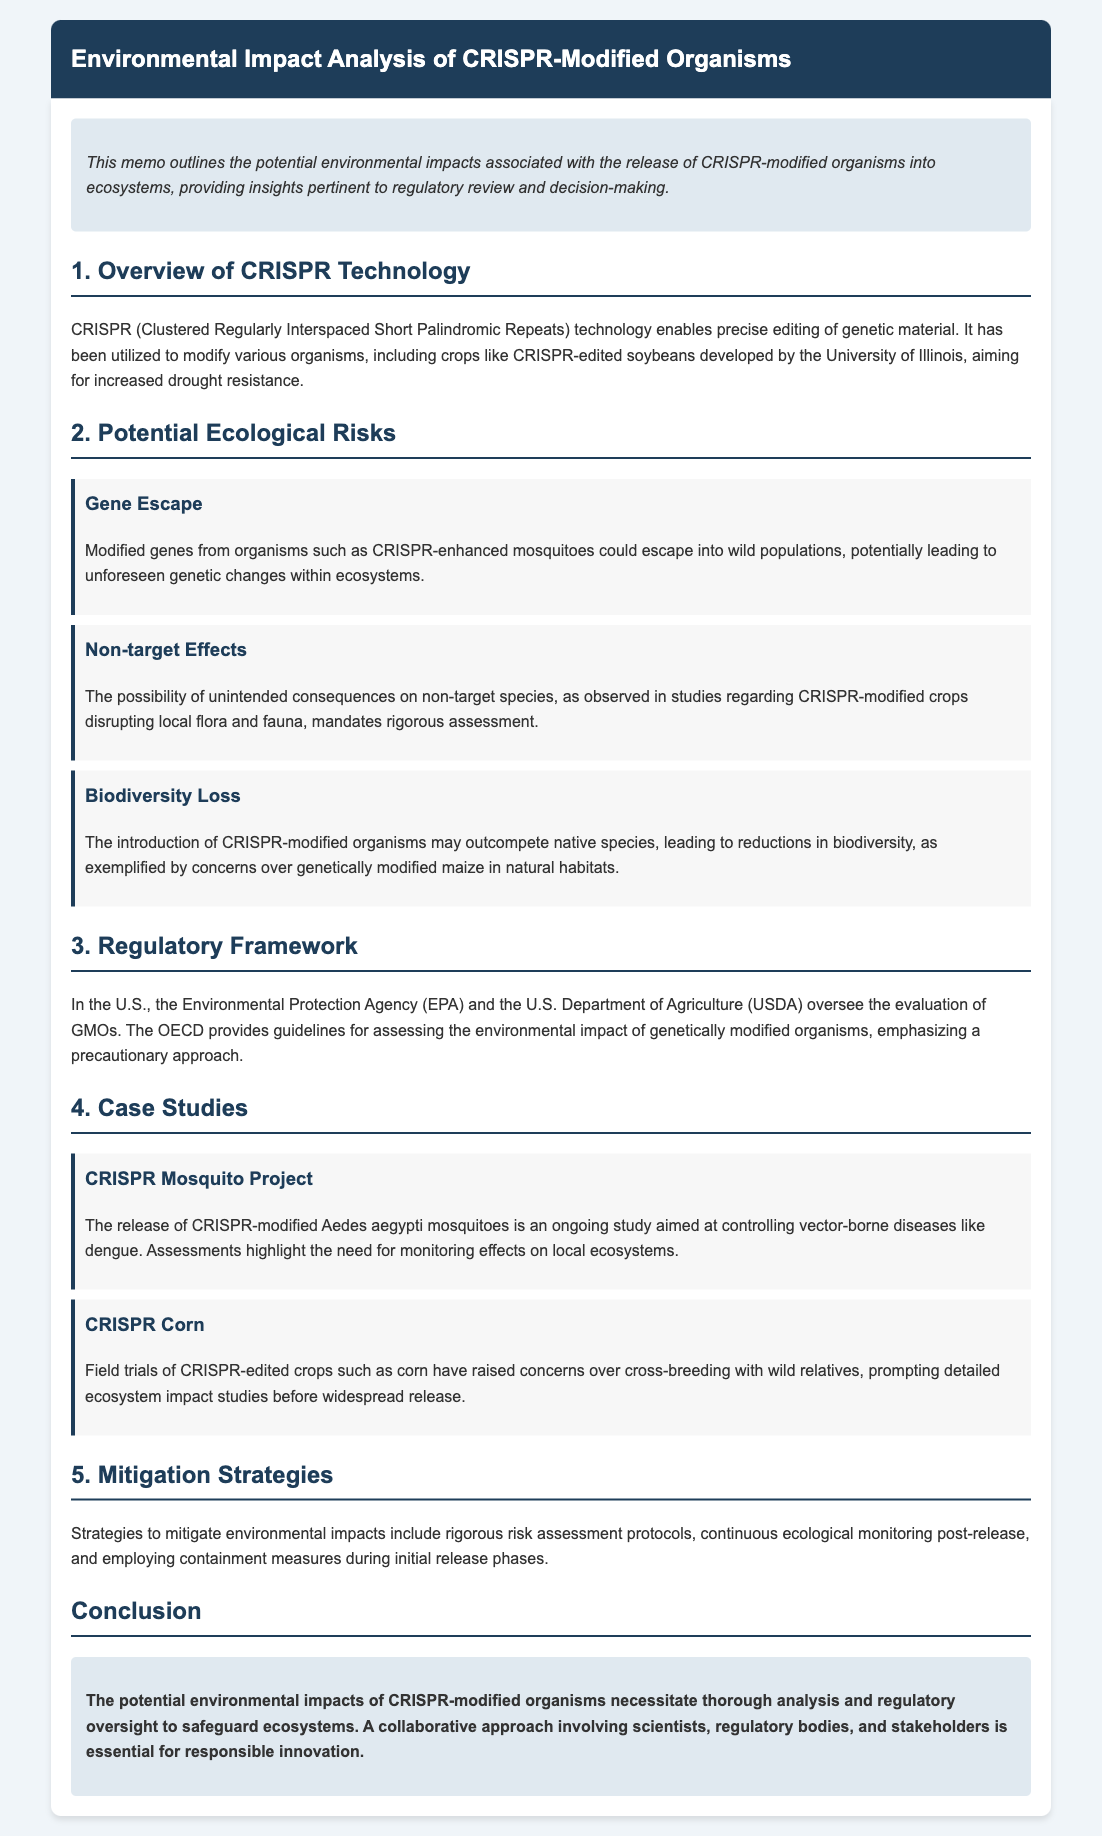What technology enables precise editing of genetic material? The document states that CRISPR (Clustered Regularly Interspaced Short Palindromic Repeats) technology enables precise editing of genetic material.
Answer: CRISPR What is a potential ecological risk associated with CRISPR-modified organisms? The document lists various risks, one of which is gene escape, indicating that modified genes could escape into wild populations.
Answer: Gene Escape Which regulatory bodies oversee the evaluation of GMOs in the U.S.? The memo mentions the Environmental Protection Agency (EPA) and the U.S. Department of Agriculture (USDA) as the overseeing bodies.
Answer: EPA and USDA What is a mitigation strategy suggested in the memo? The memo discusses several strategies, one of which includes rigorous risk assessment protocols to mitigate environmental impacts.
Answer: Rigorous risk assessment protocols What is the focus of the CRISPR Mosquito Project case study? The case study on CRISPR mosquitoes highlights efforts to control vector-borne diseases like dengue, requiring monitoring of local ecosystem effects.
Answer: Controlling vector-borne diseases How does the document characterize the potential need for monitoring after the release of CRISPR organisms? It emphasizes the need for continuous ecological monitoring post-release as a critical strategy.
Answer: Continuous ecological monitoring post-release What specific concern is raised regarding CRISPR-edited crops like corn? The document highlights concerns over cross-breeding with wild relatives among CRISPR-edited crops, prompting detailed studies.
Answer: Cross-breeding with wild relatives Who is essential for responsible innovation according to the conclusion? The conclusion states that a collaborative approach involving scientists, regulatory bodies, and stakeholders is essential for responsible innovation.
Answer: Scientists, regulatory bodies, and stakeholders 